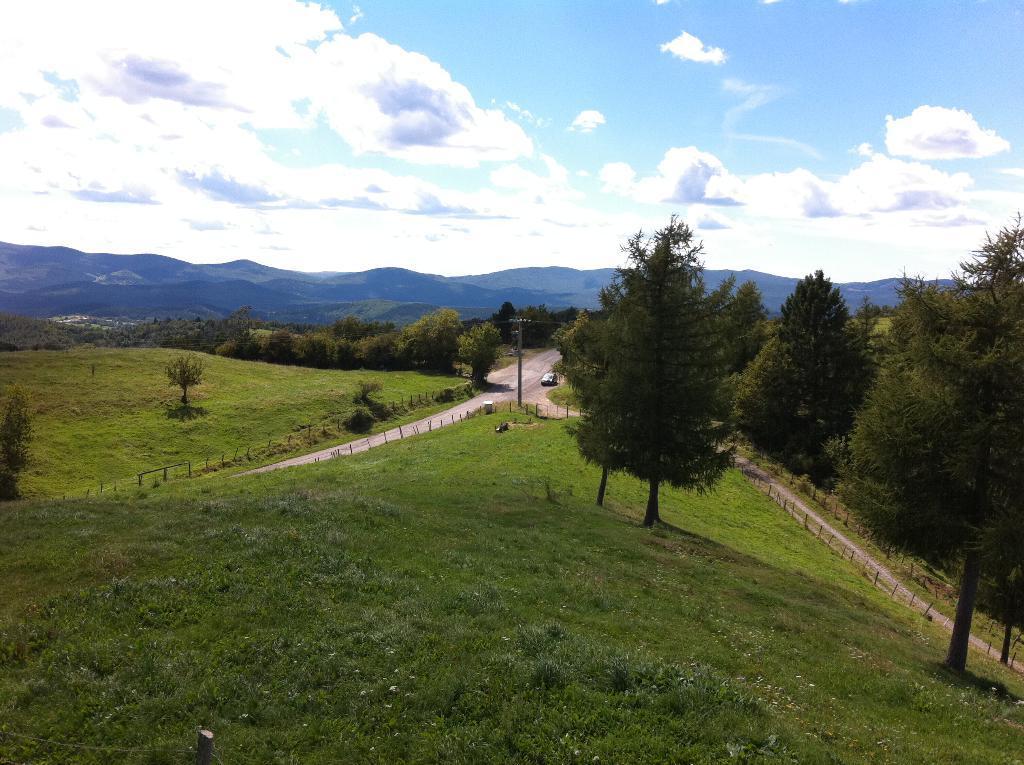Describe this image in one or two sentences. In the center of the image there is a road. There is a car on the road. At the bottom of the image there is grass. There are many trees. In the background of the image there are mountains. 